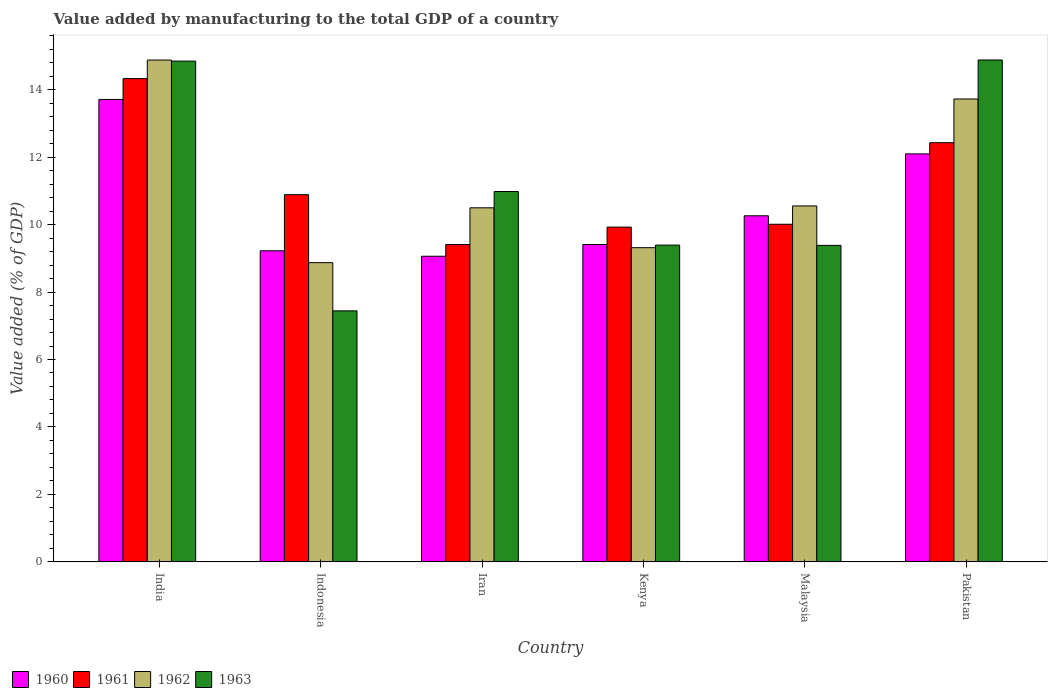How many groups of bars are there?
Provide a succinct answer. 6. Are the number of bars per tick equal to the number of legend labels?
Offer a terse response. Yes. Are the number of bars on each tick of the X-axis equal?
Keep it short and to the point. Yes. How many bars are there on the 6th tick from the left?
Provide a short and direct response. 4. What is the label of the 2nd group of bars from the left?
Provide a succinct answer. Indonesia. What is the value added by manufacturing to the total GDP in 1960 in India?
Make the answer very short. 13.71. Across all countries, what is the maximum value added by manufacturing to the total GDP in 1963?
Your response must be concise. 14.88. Across all countries, what is the minimum value added by manufacturing to the total GDP in 1961?
Make the answer very short. 9.41. In which country was the value added by manufacturing to the total GDP in 1963 minimum?
Keep it short and to the point. Indonesia. What is the total value added by manufacturing to the total GDP in 1960 in the graph?
Offer a very short reply. 63.76. What is the difference between the value added by manufacturing to the total GDP in 1960 in Malaysia and that in Pakistan?
Give a very brief answer. -1.84. What is the difference between the value added by manufacturing to the total GDP in 1963 in Malaysia and the value added by manufacturing to the total GDP in 1960 in Pakistan?
Your answer should be compact. -2.71. What is the average value added by manufacturing to the total GDP in 1961 per country?
Provide a succinct answer. 11.16. What is the difference between the value added by manufacturing to the total GDP of/in 1962 and value added by manufacturing to the total GDP of/in 1960 in India?
Offer a terse response. 1.17. In how many countries, is the value added by manufacturing to the total GDP in 1961 greater than 6 %?
Ensure brevity in your answer.  6. What is the ratio of the value added by manufacturing to the total GDP in 1963 in India to that in Kenya?
Ensure brevity in your answer.  1.58. Is the difference between the value added by manufacturing to the total GDP in 1962 in Indonesia and Pakistan greater than the difference between the value added by manufacturing to the total GDP in 1960 in Indonesia and Pakistan?
Keep it short and to the point. No. What is the difference between the highest and the second highest value added by manufacturing to the total GDP in 1963?
Your answer should be very brief. -3.9. What is the difference between the highest and the lowest value added by manufacturing to the total GDP in 1962?
Provide a succinct answer. 6.01. Is the sum of the value added by manufacturing to the total GDP in 1961 in Malaysia and Pakistan greater than the maximum value added by manufacturing to the total GDP in 1963 across all countries?
Offer a very short reply. Yes. What does the 3rd bar from the right in Malaysia represents?
Keep it short and to the point. 1961. Is it the case that in every country, the sum of the value added by manufacturing to the total GDP in 1963 and value added by manufacturing to the total GDP in 1960 is greater than the value added by manufacturing to the total GDP in 1961?
Your response must be concise. Yes. How many bars are there?
Offer a terse response. 24. Are all the bars in the graph horizontal?
Ensure brevity in your answer.  No. What is the difference between two consecutive major ticks on the Y-axis?
Make the answer very short. 2. Are the values on the major ticks of Y-axis written in scientific E-notation?
Keep it short and to the point. No. Does the graph contain any zero values?
Provide a succinct answer. No. Does the graph contain grids?
Give a very brief answer. No. Where does the legend appear in the graph?
Keep it short and to the point. Bottom left. How many legend labels are there?
Your answer should be very brief. 4. What is the title of the graph?
Your response must be concise. Value added by manufacturing to the total GDP of a country. What is the label or title of the X-axis?
Your answer should be compact. Country. What is the label or title of the Y-axis?
Your response must be concise. Value added (% of GDP). What is the Value added (% of GDP) in 1960 in India?
Keep it short and to the point. 13.71. What is the Value added (% of GDP) of 1961 in India?
Ensure brevity in your answer.  14.33. What is the Value added (% of GDP) of 1962 in India?
Offer a terse response. 14.88. What is the Value added (% of GDP) in 1963 in India?
Your response must be concise. 14.85. What is the Value added (% of GDP) in 1960 in Indonesia?
Ensure brevity in your answer.  9.22. What is the Value added (% of GDP) in 1961 in Indonesia?
Offer a terse response. 10.89. What is the Value added (% of GDP) of 1962 in Indonesia?
Your answer should be compact. 8.87. What is the Value added (% of GDP) in 1963 in Indonesia?
Keep it short and to the point. 7.44. What is the Value added (% of GDP) of 1960 in Iran?
Give a very brief answer. 9.06. What is the Value added (% of GDP) in 1961 in Iran?
Offer a terse response. 9.41. What is the Value added (% of GDP) in 1962 in Iran?
Give a very brief answer. 10.5. What is the Value added (% of GDP) in 1963 in Iran?
Offer a terse response. 10.98. What is the Value added (% of GDP) of 1960 in Kenya?
Offer a very short reply. 9.41. What is the Value added (% of GDP) of 1961 in Kenya?
Offer a very short reply. 9.93. What is the Value added (% of GDP) in 1962 in Kenya?
Provide a succinct answer. 9.32. What is the Value added (% of GDP) of 1963 in Kenya?
Offer a very short reply. 9.39. What is the Value added (% of GDP) in 1960 in Malaysia?
Keep it short and to the point. 10.26. What is the Value added (% of GDP) in 1961 in Malaysia?
Ensure brevity in your answer.  10.01. What is the Value added (% of GDP) of 1962 in Malaysia?
Offer a terse response. 10.55. What is the Value added (% of GDP) in 1963 in Malaysia?
Keep it short and to the point. 9.38. What is the Value added (% of GDP) in 1960 in Pakistan?
Offer a terse response. 12.1. What is the Value added (% of GDP) of 1961 in Pakistan?
Keep it short and to the point. 12.43. What is the Value added (% of GDP) of 1962 in Pakistan?
Offer a terse response. 13.72. What is the Value added (% of GDP) of 1963 in Pakistan?
Give a very brief answer. 14.88. Across all countries, what is the maximum Value added (% of GDP) in 1960?
Keep it short and to the point. 13.71. Across all countries, what is the maximum Value added (% of GDP) in 1961?
Your answer should be very brief. 14.33. Across all countries, what is the maximum Value added (% of GDP) of 1962?
Provide a succinct answer. 14.88. Across all countries, what is the maximum Value added (% of GDP) in 1963?
Make the answer very short. 14.88. Across all countries, what is the minimum Value added (% of GDP) in 1960?
Ensure brevity in your answer.  9.06. Across all countries, what is the minimum Value added (% of GDP) of 1961?
Your response must be concise. 9.41. Across all countries, what is the minimum Value added (% of GDP) of 1962?
Provide a succinct answer. 8.87. Across all countries, what is the minimum Value added (% of GDP) of 1963?
Keep it short and to the point. 7.44. What is the total Value added (% of GDP) in 1960 in the graph?
Make the answer very short. 63.76. What is the total Value added (% of GDP) in 1961 in the graph?
Give a very brief answer. 66.99. What is the total Value added (% of GDP) of 1962 in the graph?
Your answer should be compact. 67.84. What is the total Value added (% of GDP) in 1963 in the graph?
Your answer should be very brief. 66.93. What is the difference between the Value added (% of GDP) of 1960 in India and that in Indonesia?
Your response must be concise. 4.49. What is the difference between the Value added (% of GDP) in 1961 in India and that in Indonesia?
Make the answer very short. 3.44. What is the difference between the Value added (% of GDP) of 1962 in India and that in Indonesia?
Provide a short and direct response. 6.01. What is the difference between the Value added (% of GDP) of 1963 in India and that in Indonesia?
Keep it short and to the point. 7.4. What is the difference between the Value added (% of GDP) in 1960 in India and that in Iran?
Your answer should be very brief. 4.65. What is the difference between the Value added (% of GDP) in 1961 in India and that in Iran?
Offer a very short reply. 4.92. What is the difference between the Value added (% of GDP) of 1962 in India and that in Iran?
Provide a short and direct response. 4.38. What is the difference between the Value added (% of GDP) of 1963 in India and that in Iran?
Keep it short and to the point. 3.87. What is the difference between the Value added (% of GDP) of 1960 in India and that in Kenya?
Offer a very short reply. 4.3. What is the difference between the Value added (% of GDP) of 1961 in India and that in Kenya?
Offer a very short reply. 4.4. What is the difference between the Value added (% of GDP) in 1962 in India and that in Kenya?
Provide a succinct answer. 5.56. What is the difference between the Value added (% of GDP) of 1963 in India and that in Kenya?
Offer a terse response. 5.45. What is the difference between the Value added (% of GDP) in 1960 in India and that in Malaysia?
Your answer should be compact. 3.45. What is the difference between the Value added (% of GDP) of 1961 in India and that in Malaysia?
Give a very brief answer. 4.32. What is the difference between the Value added (% of GDP) in 1962 in India and that in Malaysia?
Ensure brevity in your answer.  4.33. What is the difference between the Value added (% of GDP) of 1963 in India and that in Malaysia?
Offer a very short reply. 5.46. What is the difference between the Value added (% of GDP) of 1960 in India and that in Pakistan?
Offer a very short reply. 1.61. What is the difference between the Value added (% of GDP) in 1961 in India and that in Pakistan?
Give a very brief answer. 1.9. What is the difference between the Value added (% of GDP) in 1962 in India and that in Pakistan?
Offer a very short reply. 1.15. What is the difference between the Value added (% of GDP) in 1963 in India and that in Pakistan?
Make the answer very short. -0.03. What is the difference between the Value added (% of GDP) in 1960 in Indonesia and that in Iran?
Provide a short and direct response. 0.16. What is the difference between the Value added (% of GDP) of 1961 in Indonesia and that in Iran?
Provide a succinct answer. 1.48. What is the difference between the Value added (% of GDP) of 1962 in Indonesia and that in Iran?
Your answer should be compact. -1.63. What is the difference between the Value added (% of GDP) in 1963 in Indonesia and that in Iran?
Your answer should be compact. -3.54. What is the difference between the Value added (% of GDP) in 1960 in Indonesia and that in Kenya?
Your answer should be very brief. -0.19. What is the difference between the Value added (% of GDP) in 1961 in Indonesia and that in Kenya?
Offer a very short reply. 0.96. What is the difference between the Value added (% of GDP) of 1962 in Indonesia and that in Kenya?
Give a very brief answer. -0.44. What is the difference between the Value added (% of GDP) in 1963 in Indonesia and that in Kenya?
Offer a terse response. -1.95. What is the difference between the Value added (% of GDP) in 1960 in Indonesia and that in Malaysia?
Offer a very short reply. -1.04. What is the difference between the Value added (% of GDP) of 1961 in Indonesia and that in Malaysia?
Make the answer very short. 0.88. What is the difference between the Value added (% of GDP) of 1962 in Indonesia and that in Malaysia?
Your response must be concise. -1.68. What is the difference between the Value added (% of GDP) in 1963 in Indonesia and that in Malaysia?
Ensure brevity in your answer.  -1.94. What is the difference between the Value added (% of GDP) in 1960 in Indonesia and that in Pakistan?
Offer a very short reply. -2.87. What is the difference between the Value added (% of GDP) in 1961 in Indonesia and that in Pakistan?
Make the answer very short. -1.54. What is the difference between the Value added (% of GDP) of 1962 in Indonesia and that in Pakistan?
Make the answer very short. -4.85. What is the difference between the Value added (% of GDP) of 1963 in Indonesia and that in Pakistan?
Make the answer very short. -7.44. What is the difference between the Value added (% of GDP) in 1960 in Iran and that in Kenya?
Your answer should be very brief. -0.35. What is the difference between the Value added (% of GDP) in 1961 in Iran and that in Kenya?
Your answer should be very brief. -0.52. What is the difference between the Value added (% of GDP) of 1962 in Iran and that in Kenya?
Offer a terse response. 1.18. What is the difference between the Value added (% of GDP) in 1963 in Iran and that in Kenya?
Your answer should be very brief. 1.59. What is the difference between the Value added (% of GDP) in 1960 in Iran and that in Malaysia?
Offer a very short reply. -1.2. What is the difference between the Value added (% of GDP) in 1961 in Iran and that in Malaysia?
Your response must be concise. -0.6. What is the difference between the Value added (% of GDP) in 1962 in Iran and that in Malaysia?
Give a very brief answer. -0.06. What is the difference between the Value added (% of GDP) of 1963 in Iran and that in Malaysia?
Make the answer very short. 1.6. What is the difference between the Value added (% of GDP) of 1960 in Iran and that in Pakistan?
Your answer should be compact. -3.03. What is the difference between the Value added (% of GDP) of 1961 in Iran and that in Pakistan?
Offer a very short reply. -3.02. What is the difference between the Value added (% of GDP) in 1962 in Iran and that in Pakistan?
Offer a terse response. -3.23. What is the difference between the Value added (% of GDP) in 1960 in Kenya and that in Malaysia?
Make the answer very short. -0.85. What is the difference between the Value added (% of GDP) in 1961 in Kenya and that in Malaysia?
Give a very brief answer. -0.08. What is the difference between the Value added (% of GDP) of 1962 in Kenya and that in Malaysia?
Provide a succinct answer. -1.24. What is the difference between the Value added (% of GDP) in 1963 in Kenya and that in Malaysia?
Offer a very short reply. 0.01. What is the difference between the Value added (% of GDP) in 1960 in Kenya and that in Pakistan?
Your answer should be very brief. -2.69. What is the difference between the Value added (% of GDP) of 1961 in Kenya and that in Pakistan?
Ensure brevity in your answer.  -2.5. What is the difference between the Value added (% of GDP) of 1962 in Kenya and that in Pakistan?
Your answer should be very brief. -4.41. What is the difference between the Value added (% of GDP) of 1963 in Kenya and that in Pakistan?
Your answer should be compact. -5.49. What is the difference between the Value added (% of GDP) in 1960 in Malaysia and that in Pakistan?
Offer a terse response. -1.84. What is the difference between the Value added (% of GDP) of 1961 in Malaysia and that in Pakistan?
Keep it short and to the point. -2.42. What is the difference between the Value added (% of GDP) in 1962 in Malaysia and that in Pakistan?
Give a very brief answer. -3.17. What is the difference between the Value added (% of GDP) in 1963 in Malaysia and that in Pakistan?
Ensure brevity in your answer.  -5.5. What is the difference between the Value added (% of GDP) in 1960 in India and the Value added (% of GDP) in 1961 in Indonesia?
Offer a very short reply. 2.82. What is the difference between the Value added (% of GDP) of 1960 in India and the Value added (% of GDP) of 1962 in Indonesia?
Offer a very short reply. 4.84. What is the difference between the Value added (% of GDP) of 1960 in India and the Value added (% of GDP) of 1963 in Indonesia?
Your answer should be very brief. 6.27. What is the difference between the Value added (% of GDP) in 1961 in India and the Value added (% of GDP) in 1962 in Indonesia?
Provide a short and direct response. 5.46. What is the difference between the Value added (% of GDP) in 1961 in India and the Value added (% of GDP) in 1963 in Indonesia?
Give a very brief answer. 6.89. What is the difference between the Value added (% of GDP) of 1962 in India and the Value added (% of GDP) of 1963 in Indonesia?
Your response must be concise. 7.44. What is the difference between the Value added (% of GDP) in 1960 in India and the Value added (% of GDP) in 1961 in Iran?
Make the answer very short. 4.3. What is the difference between the Value added (% of GDP) in 1960 in India and the Value added (% of GDP) in 1962 in Iran?
Make the answer very short. 3.21. What is the difference between the Value added (% of GDP) of 1960 in India and the Value added (% of GDP) of 1963 in Iran?
Provide a short and direct response. 2.73. What is the difference between the Value added (% of GDP) of 1961 in India and the Value added (% of GDP) of 1962 in Iran?
Provide a succinct answer. 3.83. What is the difference between the Value added (% of GDP) of 1961 in India and the Value added (% of GDP) of 1963 in Iran?
Your answer should be compact. 3.35. What is the difference between the Value added (% of GDP) of 1962 in India and the Value added (% of GDP) of 1963 in Iran?
Offer a terse response. 3.9. What is the difference between the Value added (% of GDP) of 1960 in India and the Value added (% of GDP) of 1961 in Kenya?
Your answer should be compact. 3.78. What is the difference between the Value added (% of GDP) of 1960 in India and the Value added (% of GDP) of 1962 in Kenya?
Provide a succinct answer. 4.39. What is the difference between the Value added (% of GDP) of 1960 in India and the Value added (% of GDP) of 1963 in Kenya?
Your answer should be very brief. 4.32. What is the difference between the Value added (% of GDP) of 1961 in India and the Value added (% of GDP) of 1962 in Kenya?
Keep it short and to the point. 5.01. What is the difference between the Value added (% of GDP) in 1961 in India and the Value added (% of GDP) in 1963 in Kenya?
Make the answer very short. 4.94. What is the difference between the Value added (% of GDP) of 1962 in India and the Value added (% of GDP) of 1963 in Kenya?
Provide a short and direct response. 5.49. What is the difference between the Value added (% of GDP) in 1960 in India and the Value added (% of GDP) in 1961 in Malaysia?
Offer a very short reply. 3.7. What is the difference between the Value added (% of GDP) of 1960 in India and the Value added (% of GDP) of 1962 in Malaysia?
Provide a short and direct response. 3.16. What is the difference between the Value added (% of GDP) of 1960 in India and the Value added (% of GDP) of 1963 in Malaysia?
Ensure brevity in your answer.  4.33. What is the difference between the Value added (% of GDP) in 1961 in India and the Value added (% of GDP) in 1962 in Malaysia?
Give a very brief answer. 3.78. What is the difference between the Value added (% of GDP) of 1961 in India and the Value added (% of GDP) of 1963 in Malaysia?
Keep it short and to the point. 4.94. What is the difference between the Value added (% of GDP) of 1962 in India and the Value added (% of GDP) of 1963 in Malaysia?
Provide a short and direct response. 5.49. What is the difference between the Value added (% of GDP) of 1960 in India and the Value added (% of GDP) of 1961 in Pakistan?
Offer a very short reply. 1.28. What is the difference between the Value added (% of GDP) in 1960 in India and the Value added (% of GDP) in 1962 in Pakistan?
Provide a short and direct response. -0.01. What is the difference between the Value added (% of GDP) of 1960 in India and the Value added (% of GDP) of 1963 in Pakistan?
Your answer should be very brief. -1.17. What is the difference between the Value added (% of GDP) of 1961 in India and the Value added (% of GDP) of 1962 in Pakistan?
Your response must be concise. 0.6. What is the difference between the Value added (% of GDP) of 1961 in India and the Value added (% of GDP) of 1963 in Pakistan?
Your answer should be very brief. -0.55. What is the difference between the Value added (% of GDP) in 1962 in India and the Value added (% of GDP) in 1963 in Pakistan?
Provide a short and direct response. -0. What is the difference between the Value added (% of GDP) in 1960 in Indonesia and the Value added (% of GDP) in 1961 in Iran?
Your answer should be compact. -0.18. What is the difference between the Value added (% of GDP) in 1960 in Indonesia and the Value added (% of GDP) in 1962 in Iran?
Your answer should be compact. -1.27. What is the difference between the Value added (% of GDP) of 1960 in Indonesia and the Value added (% of GDP) of 1963 in Iran?
Keep it short and to the point. -1.76. What is the difference between the Value added (% of GDP) of 1961 in Indonesia and the Value added (% of GDP) of 1962 in Iran?
Offer a very short reply. 0.39. What is the difference between the Value added (% of GDP) of 1961 in Indonesia and the Value added (% of GDP) of 1963 in Iran?
Ensure brevity in your answer.  -0.09. What is the difference between the Value added (% of GDP) of 1962 in Indonesia and the Value added (% of GDP) of 1963 in Iran?
Provide a succinct answer. -2.11. What is the difference between the Value added (% of GDP) of 1960 in Indonesia and the Value added (% of GDP) of 1961 in Kenya?
Make the answer very short. -0.7. What is the difference between the Value added (% of GDP) of 1960 in Indonesia and the Value added (% of GDP) of 1962 in Kenya?
Offer a very short reply. -0.09. What is the difference between the Value added (% of GDP) in 1960 in Indonesia and the Value added (% of GDP) in 1963 in Kenya?
Give a very brief answer. -0.17. What is the difference between the Value added (% of GDP) in 1961 in Indonesia and the Value added (% of GDP) in 1962 in Kenya?
Provide a short and direct response. 1.57. What is the difference between the Value added (% of GDP) of 1961 in Indonesia and the Value added (% of GDP) of 1963 in Kenya?
Your answer should be compact. 1.5. What is the difference between the Value added (% of GDP) in 1962 in Indonesia and the Value added (% of GDP) in 1963 in Kenya?
Give a very brief answer. -0.52. What is the difference between the Value added (% of GDP) in 1960 in Indonesia and the Value added (% of GDP) in 1961 in Malaysia?
Your answer should be compact. -0.79. What is the difference between the Value added (% of GDP) in 1960 in Indonesia and the Value added (% of GDP) in 1962 in Malaysia?
Provide a short and direct response. -1.33. What is the difference between the Value added (% of GDP) in 1960 in Indonesia and the Value added (% of GDP) in 1963 in Malaysia?
Your answer should be compact. -0.16. What is the difference between the Value added (% of GDP) of 1961 in Indonesia and the Value added (% of GDP) of 1962 in Malaysia?
Offer a very short reply. 0.33. What is the difference between the Value added (% of GDP) in 1961 in Indonesia and the Value added (% of GDP) in 1963 in Malaysia?
Your answer should be compact. 1.5. What is the difference between the Value added (% of GDP) in 1962 in Indonesia and the Value added (% of GDP) in 1963 in Malaysia?
Your response must be concise. -0.51. What is the difference between the Value added (% of GDP) in 1960 in Indonesia and the Value added (% of GDP) in 1961 in Pakistan?
Your answer should be compact. -3.2. What is the difference between the Value added (% of GDP) of 1960 in Indonesia and the Value added (% of GDP) of 1962 in Pakistan?
Your answer should be very brief. -4.5. What is the difference between the Value added (% of GDP) of 1960 in Indonesia and the Value added (% of GDP) of 1963 in Pakistan?
Ensure brevity in your answer.  -5.66. What is the difference between the Value added (% of GDP) of 1961 in Indonesia and the Value added (% of GDP) of 1962 in Pakistan?
Give a very brief answer. -2.84. What is the difference between the Value added (% of GDP) in 1961 in Indonesia and the Value added (% of GDP) in 1963 in Pakistan?
Offer a terse response. -3.99. What is the difference between the Value added (% of GDP) in 1962 in Indonesia and the Value added (% of GDP) in 1963 in Pakistan?
Offer a very short reply. -6.01. What is the difference between the Value added (% of GDP) of 1960 in Iran and the Value added (% of GDP) of 1961 in Kenya?
Ensure brevity in your answer.  -0.86. What is the difference between the Value added (% of GDP) in 1960 in Iran and the Value added (% of GDP) in 1962 in Kenya?
Offer a terse response. -0.25. What is the difference between the Value added (% of GDP) in 1960 in Iran and the Value added (% of GDP) in 1963 in Kenya?
Offer a very short reply. -0.33. What is the difference between the Value added (% of GDP) of 1961 in Iran and the Value added (% of GDP) of 1962 in Kenya?
Give a very brief answer. 0.09. What is the difference between the Value added (% of GDP) in 1961 in Iran and the Value added (% of GDP) in 1963 in Kenya?
Provide a short and direct response. 0.02. What is the difference between the Value added (% of GDP) of 1962 in Iran and the Value added (% of GDP) of 1963 in Kenya?
Provide a short and direct response. 1.11. What is the difference between the Value added (% of GDP) of 1960 in Iran and the Value added (% of GDP) of 1961 in Malaysia?
Offer a very short reply. -0.95. What is the difference between the Value added (% of GDP) in 1960 in Iran and the Value added (% of GDP) in 1962 in Malaysia?
Make the answer very short. -1.49. What is the difference between the Value added (% of GDP) in 1960 in Iran and the Value added (% of GDP) in 1963 in Malaysia?
Provide a short and direct response. -0.32. What is the difference between the Value added (% of GDP) of 1961 in Iran and the Value added (% of GDP) of 1962 in Malaysia?
Your answer should be compact. -1.14. What is the difference between the Value added (% of GDP) of 1961 in Iran and the Value added (% of GDP) of 1963 in Malaysia?
Your answer should be compact. 0.03. What is the difference between the Value added (% of GDP) in 1962 in Iran and the Value added (% of GDP) in 1963 in Malaysia?
Give a very brief answer. 1.11. What is the difference between the Value added (% of GDP) in 1960 in Iran and the Value added (% of GDP) in 1961 in Pakistan?
Provide a succinct answer. -3.37. What is the difference between the Value added (% of GDP) in 1960 in Iran and the Value added (% of GDP) in 1962 in Pakistan?
Keep it short and to the point. -4.66. What is the difference between the Value added (% of GDP) in 1960 in Iran and the Value added (% of GDP) in 1963 in Pakistan?
Provide a succinct answer. -5.82. What is the difference between the Value added (% of GDP) of 1961 in Iran and the Value added (% of GDP) of 1962 in Pakistan?
Give a very brief answer. -4.32. What is the difference between the Value added (% of GDP) in 1961 in Iran and the Value added (% of GDP) in 1963 in Pakistan?
Make the answer very short. -5.47. What is the difference between the Value added (% of GDP) of 1962 in Iran and the Value added (% of GDP) of 1963 in Pakistan?
Give a very brief answer. -4.38. What is the difference between the Value added (% of GDP) of 1960 in Kenya and the Value added (% of GDP) of 1961 in Malaysia?
Your answer should be compact. -0.6. What is the difference between the Value added (% of GDP) of 1960 in Kenya and the Value added (% of GDP) of 1962 in Malaysia?
Offer a terse response. -1.14. What is the difference between the Value added (% of GDP) in 1960 in Kenya and the Value added (% of GDP) in 1963 in Malaysia?
Your answer should be very brief. 0.03. What is the difference between the Value added (% of GDP) in 1961 in Kenya and the Value added (% of GDP) in 1962 in Malaysia?
Ensure brevity in your answer.  -0.63. What is the difference between the Value added (% of GDP) of 1961 in Kenya and the Value added (% of GDP) of 1963 in Malaysia?
Your answer should be very brief. 0.54. What is the difference between the Value added (% of GDP) in 1962 in Kenya and the Value added (% of GDP) in 1963 in Malaysia?
Offer a terse response. -0.07. What is the difference between the Value added (% of GDP) of 1960 in Kenya and the Value added (% of GDP) of 1961 in Pakistan?
Provide a short and direct response. -3.02. What is the difference between the Value added (% of GDP) in 1960 in Kenya and the Value added (% of GDP) in 1962 in Pakistan?
Make the answer very short. -4.31. What is the difference between the Value added (% of GDP) in 1960 in Kenya and the Value added (% of GDP) in 1963 in Pakistan?
Provide a succinct answer. -5.47. What is the difference between the Value added (% of GDP) in 1961 in Kenya and the Value added (% of GDP) in 1962 in Pakistan?
Provide a succinct answer. -3.8. What is the difference between the Value added (% of GDP) of 1961 in Kenya and the Value added (% of GDP) of 1963 in Pakistan?
Make the answer very short. -4.96. What is the difference between the Value added (% of GDP) of 1962 in Kenya and the Value added (% of GDP) of 1963 in Pakistan?
Your answer should be very brief. -5.57. What is the difference between the Value added (% of GDP) in 1960 in Malaysia and the Value added (% of GDP) in 1961 in Pakistan?
Ensure brevity in your answer.  -2.17. What is the difference between the Value added (% of GDP) in 1960 in Malaysia and the Value added (% of GDP) in 1962 in Pakistan?
Ensure brevity in your answer.  -3.46. What is the difference between the Value added (% of GDP) of 1960 in Malaysia and the Value added (% of GDP) of 1963 in Pakistan?
Offer a terse response. -4.62. What is the difference between the Value added (% of GDP) of 1961 in Malaysia and the Value added (% of GDP) of 1962 in Pakistan?
Your answer should be very brief. -3.71. What is the difference between the Value added (% of GDP) in 1961 in Malaysia and the Value added (% of GDP) in 1963 in Pakistan?
Provide a succinct answer. -4.87. What is the difference between the Value added (% of GDP) of 1962 in Malaysia and the Value added (% of GDP) of 1963 in Pakistan?
Your answer should be very brief. -4.33. What is the average Value added (% of GDP) of 1960 per country?
Provide a succinct answer. 10.63. What is the average Value added (% of GDP) in 1961 per country?
Give a very brief answer. 11.16. What is the average Value added (% of GDP) in 1962 per country?
Provide a succinct answer. 11.31. What is the average Value added (% of GDP) in 1963 per country?
Offer a terse response. 11.15. What is the difference between the Value added (% of GDP) of 1960 and Value added (% of GDP) of 1961 in India?
Ensure brevity in your answer.  -0.62. What is the difference between the Value added (% of GDP) of 1960 and Value added (% of GDP) of 1962 in India?
Give a very brief answer. -1.17. What is the difference between the Value added (% of GDP) of 1960 and Value added (% of GDP) of 1963 in India?
Give a very brief answer. -1.14. What is the difference between the Value added (% of GDP) of 1961 and Value added (% of GDP) of 1962 in India?
Offer a very short reply. -0.55. What is the difference between the Value added (% of GDP) of 1961 and Value added (% of GDP) of 1963 in India?
Ensure brevity in your answer.  -0.52. What is the difference between the Value added (% of GDP) in 1962 and Value added (% of GDP) in 1963 in India?
Ensure brevity in your answer.  0.03. What is the difference between the Value added (% of GDP) in 1960 and Value added (% of GDP) in 1961 in Indonesia?
Your answer should be very brief. -1.66. What is the difference between the Value added (% of GDP) in 1960 and Value added (% of GDP) in 1962 in Indonesia?
Provide a succinct answer. 0.35. What is the difference between the Value added (% of GDP) of 1960 and Value added (% of GDP) of 1963 in Indonesia?
Provide a short and direct response. 1.78. What is the difference between the Value added (% of GDP) of 1961 and Value added (% of GDP) of 1962 in Indonesia?
Your response must be concise. 2.02. What is the difference between the Value added (% of GDP) of 1961 and Value added (% of GDP) of 1963 in Indonesia?
Make the answer very short. 3.44. What is the difference between the Value added (% of GDP) in 1962 and Value added (% of GDP) in 1963 in Indonesia?
Make the answer very short. 1.43. What is the difference between the Value added (% of GDP) of 1960 and Value added (% of GDP) of 1961 in Iran?
Your response must be concise. -0.35. What is the difference between the Value added (% of GDP) in 1960 and Value added (% of GDP) in 1962 in Iran?
Provide a succinct answer. -1.44. What is the difference between the Value added (% of GDP) of 1960 and Value added (% of GDP) of 1963 in Iran?
Your response must be concise. -1.92. What is the difference between the Value added (% of GDP) in 1961 and Value added (% of GDP) in 1962 in Iran?
Ensure brevity in your answer.  -1.09. What is the difference between the Value added (% of GDP) in 1961 and Value added (% of GDP) in 1963 in Iran?
Provide a succinct answer. -1.57. What is the difference between the Value added (% of GDP) in 1962 and Value added (% of GDP) in 1963 in Iran?
Keep it short and to the point. -0.48. What is the difference between the Value added (% of GDP) of 1960 and Value added (% of GDP) of 1961 in Kenya?
Ensure brevity in your answer.  -0.52. What is the difference between the Value added (% of GDP) of 1960 and Value added (% of GDP) of 1962 in Kenya?
Your response must be concise. 0.09. What is the difference between the Value added (% of GDP) of 1960 and Value added (% of GDP) of 1963 in Kenya?
Provide a short and direct response. 0.02. What is the difference between the Value added (% of GDP) of 1961 and Value added (% of GDP) of 1962 in Kenya?
Your response must be concise. 0.61. What is the difference between the Value added (% of GDP) of 1961 and Value added (% of GDP) of 1963 in Kenya?
Provide a succinct answer. 0.53. What is the difference between the Value added (% of GDP) of 1962 and Value added (% of GDP) of 1963 in Kenya?
Keep it short and to the point. -0.08. What is the difference between the Value added (% of GDP) in 1960 and Value added (% of GDP) in 1961 in Malaysia?
Give a very brief answer. 0.25. What is the difference between the Value added (% of GDP) of 1960 and Value added (% of GDP) of 1962 in Malaysia?
Offer a very short reply. -0.29. What is the difference between the Value added (% of GDP) of 1960 and Value added (% of GDP) of 1963 in Malaysia?
Provide a succinct answer. 0.88. What is the difference between the Value added (% of GDP) in 1961 and Value added (% of GDP) in 1962 in Malaysia?
Your response must be concise. -0.54. What is the difference between the Value added (% of GDP) of 1961 and Value added (% of GDP) of 1963 in Malaysia?
Your answer should be very brief. 0.63. What is the difference between the Value added (% of GDP) in 1962 and Value added (% of GDP) in 1963 in Malaysia?
Offer a terse response. 1.17. What is the difference between the Value added (% of GDP) in 1960 and Value added (% of GDP) in 1961 in Pakistan?
Provide a short and direct response. -0.33. What is the difference between the Value added (% of GDP) of 1960 and Value added (% of GDP) of 1962 in Pakistan?
Ensure brevity in your answer.  -1.63. What is the difference between the Value added (% of GDP) of 1960 and Value added (% of GDP) of 1963 in Pakistan?
Your answer should be compact. -2.78. What is the difference between the Value added (% of GDP) of 1961 and Value added (% of GDP) of 1962 in Pakistan?
Your answer should be very brief. -1.3. What is the difference between the Value added (% of GDP) of 1961 and Value added (% of GDP) of 1963 in Pakistan?
Keep it short and to the point. -2.45. What is the difference between the Value added (% of GDP) of 1962 and Value added (% of GDP) of 1963 in Pakistan?
Provide a short and direct response. -1.16. What is the ratio of the Value added (% of GDP) of 1960 in India to that in Indonesia?
Your answer should be compact. 1.49. What is the ratio of the Value added (% of GDP) of 1961 in India to that in Indonesia?
Provide a short and direct response. 1.32. What is the ratio of the Value added (% of GDP) of 1962 in India to that in Indonesia?
Make the answer very short. 1.68. What is the ratio of the Value added (% of GDP) of 1963 in India to that in Indonesia?
Provide a succinct answer. 1.99. What is the ratio of the Value added (% of GDP) of 1960 in India to that in Iran?
Keep it short and to the point. 1.51. What is the ratio of the Value added (% of GDP) of 1961 in India to that in Iran?
Offer a terse response. 1.52. What is the ratio of the Value added (% of GDP) of 1962 in India to that in Iran?
Keep it short and to the point. 1.42. What is the ratio of the Value added (% of GDP) of 1963 in India to that in Iran?
Make the answer very short. 1.35. What is the ratio of the Value added (% of GDP) of 1960 in India to that in Kenya?
Your answer should be compact. 1.46. What is the ratio of the Value added (% of GDP) of 1961 in India to that in Kenya?
Provide a short and direct response. 1.44. What is the ratio of the Value added (% of GDP) of 1962 in India to that in Kenya?
Provide a short and direct response. 1.6. What is the ratio of the Value added (% of GDP) in 1963 in India to that in Kenya?
Give a very brief answer. 1.58. What is the ratio of the Value added (% of GDP) of 1960 in India to that in Malaysia?
Provide a succinct answer. 1.34. What is the ratio of the Value added (% of GDP) of 1961 in India to that in Malaysia?
Ensure brevity in your answer.  1.43. What is the ratio of the Value added (% of GDP) in 1962 in India to that in Malaysia?
Provide a short and direct response. 1.41. What is the ratio of the Value added (% of GDP) of 1963 in India to that in Malaysia?
Your response must be concise. 1.58. What is the ratio of the Value added (% of GDP) in 1960 in India to that in Pakistan?
Provide a succinct answer. 1.13. What is the ratio of the Value added (% of GDP) in 1961 in India to that in Pakistan?
Provide a short and direct response. 1.15. What is the ratio of the Value added (% of GDP) in 1962 in India to that in Pakistan?
Offer a terse response. 1.08. What is the ratio of the Value added (% of GDP) in 1963 in India to that in Pakistan?
Offer a very short reply. 1. What is the ratio of the Value added (% of GDP) in 1960 in Indonesia to that in Iran?
Make the answer very short. 1.02. What is the ratio of the Value added (% of GDP) in 1961 in Indonesia to that in Iran?
Provide a short and direct response. 1.16. What is the ratio of the Value added (% of GDP) in 1962 in Indonesia to that in Iran?
Provide a short and direct response. 0.85. What is the ratio of the Value added (% of GDP) of 1963 in Indonesia to that in Iran?
Keep it short and to the point. 0.68. What is the ratio of the Value added (% of GDP) of 1960 in Indonesia to that in Kenya?
Give a very brief answer. 0.98. What is the ratio of the Value added (% of GDP) of 1961 in Indonesia to that in Kenya?
Ensure brevity in your answer.  1.1. What is the ratio of the Value added (% of GDP) in 1963 in Indonesia to that in Kenya?
Offer a terse response. 0.79. What is the ratio of the Value added (% of GDP) in 1960 in Indonesia to that in Malaysia?
Provide a short and direct response. 0.9. What is the ratio of the Value added (% of GDP) of 1961 in Indonesia to that in Malaysia?
Your answer should be compact. 1.09. What is the ratio of the Value added (% of GDP) in 1962 in Indonesia to that in Malaysia?
Your response must be concise. 0.84. What is the ratio of the Value added (% of GDP) in 1963 in Indonesia to that in Malaysia?
Offer a very short reply. 0.79. What is the ratio of the Value added (% of GDP) in 1960 in Indonesia to that in Pakistan?
Offer a very short reply. 0.76. What is the ratio of the Value added (% of GDP) in 1961 in Indonesia to that in Pakistan?
Give a very brief answer. 0.88. What is the ratio of the Value added (% of GDP) in 1962 in Indonesia to that in Pakistan?
Your answer should be compact. 0.65. What is the ratio of the Value added (% of GDP) in 1963 in Indonesia to that in Pakistan?
Your answer should be very brief. 0.5. What is the ratio of the Value added (% of GDP) of 1960 in Iran to that in Kenya?
Ensure brevity in your answer.  0.96. What is the ratio of the Value added (% of GDP) of 1961 in Iran to that in Kenya?
Give a very brief answer. 0.95. What is the ratio of the Value added (% of GDP) in 1962 in Iran to that in Kenya?
Provide a short and direct response. 1.13. What is the ratio of the Value added (% of GDP) in 1963 in Iran to that in Kenya?
Ensure brevity in your answer.  1.17. What is the ratio of the Value added (% of GDP) of 1960 in Iran to that in Malaysia?
Your response must be concise. 0.88. What is the ratio of the Value added (% of GDP) in 1961 in Iran to that in Malaysia?
Your answer should be very brief. 0.94. What is the ratio of the Value added (% of GDP) in 1963 in Iran to that in Malaysia?
Offer a terse response. 1.17. What is the ratio of the Value added (% of GDP) in 1960 in Iran to that in Pakistan?
Ensure brevity in your answer.  0.75. What is the ratio of the Value added (% of GDP) in 1961 in Iran to that in Pakistan?
Make the answer very short. 0.76. What is the ratio of the Value added (% of GDP) of 1962 in Iran to that in Pakistan?
Offer a very short reply. 0.76. What is the ratio of the Value added (% of GDP) of 1963 in Iran to that in Pakistan?
Offer a terse response. 0.74. What is the ratio of the Value added (% of GDP) in 1960 in Kenya to that in Malaysia?
Ensure brevity in your answer.  0.92. What is the ratio of the Value added (% of GDP) in 1962 in Kenya to that in Malaysia?
Offer a very short reply. 0.88. What is the ratio of the Value added (% of GDP) of 1960 in Kenya to that in Pakistan?
Your answer should be very brief. 0.78. What is the ratio of the Value added (% of GDP) of 1961 in Kenya to that in Pakistan?
Ensure brevity in your answer.  0.8. What is the ratio of the Value added (% of GDP) in 1962 in Kenya to that in Pakistan?
Ensure brevity in your answer.  0.68. What is the ratio of the Value added (% of GDP) in 1963 in Kenya to that in Pakistan?
Give a very brief answer. 0.63. What is the ratio of the Value added (% of GDP) of 1960 in Malaysia to that in Pakistan?
Your answer should be very brief. 0.85. What is the ratio of the Value added (% of GDP) in 1961 in Malaysia to that in Pakistan?
Offer a very short reply. 0.81. What is the ratio of the Value added (% of GDP) in 1962 in Malaysia to that in Pakistan?
Provide a succinct answer. 0.77. What is the ratio of the Value added (% of GDP) in 1963 in Malaysia to that in Pakistan?
Your answer should be compact. 0.63. What is the difference between the highest and the second highest Value added (% of GDP) of 1960?
Your answer should be compact. 1.61. What is the difference between the highest and the second highest Value added (% of GDP) of 1961?
Make the answer very short. 1.9. What is the difference between the highest and the second highest Value added (% of GDP) of 1962?
Your answer should be very brief. 1.15. What is the difference between the highest and the second highest Value added (% of GDP) of 1963?
Provide a short and direct response. 0.03. What is the difference between the highest and the lowest Value added (% of GDP) in 1960?
Your answer should be very brief. 4.65. What is the difference between the highest and the lowest Value added (% of GDP) in 1961?
Provide a succinct answer. 4.92. What is the difference between the highest and the lowest Value added (% of GDP) in 1962?
Make the answer very short. 6.01. What is the difference between the highest and the lowest Value added (% of GDP) of 1963?
Your answer should be compact. 7.44. 